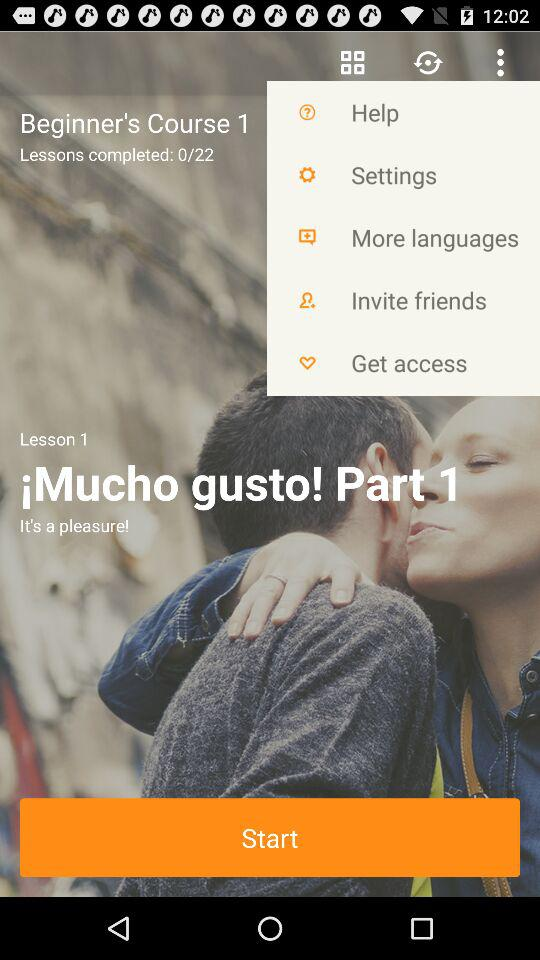How many lessons in total are there? There are 22 lessons. 